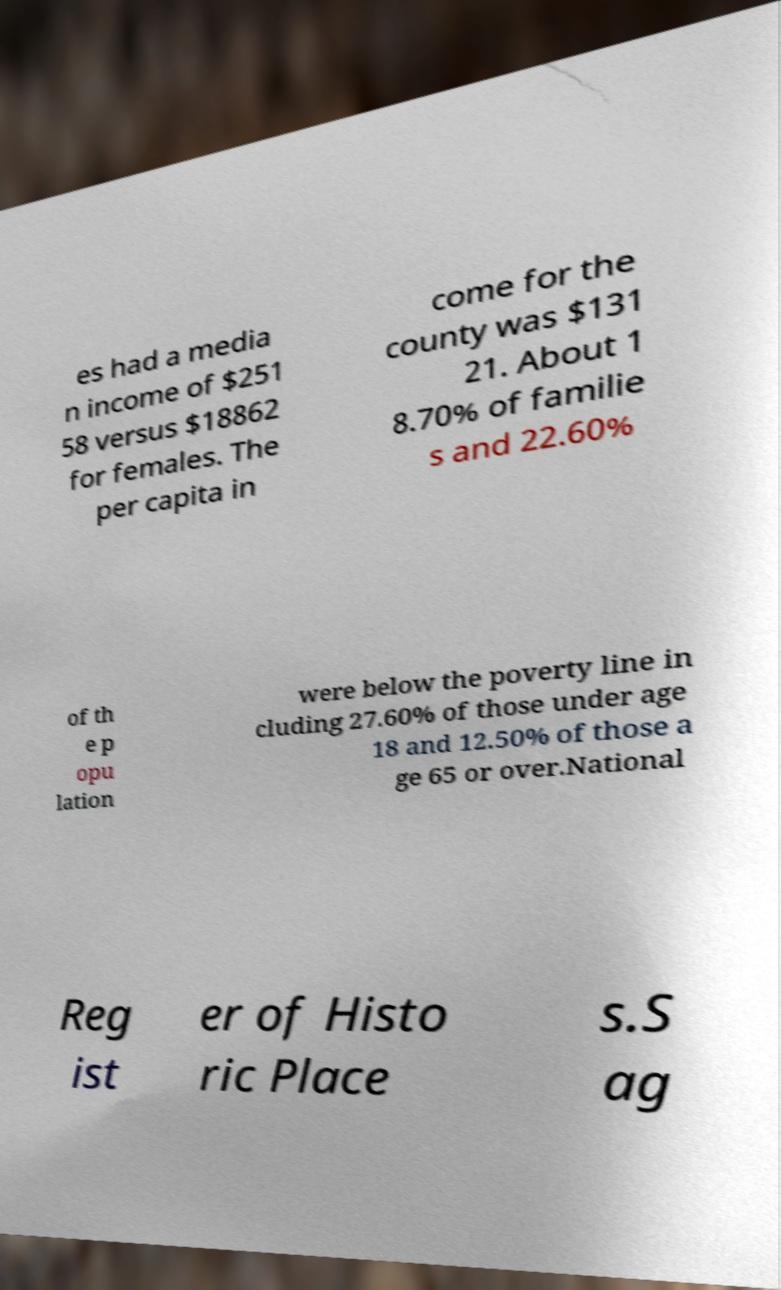Could you extract and type out the text from this image? es had a media n income of $251 58 versus $18862 for females. The per capita in come for the county was $131 21. About 1 8.70% of familie s and 22.60% of th e p opu lation were below the poverty line in cluding 27.60% of those under age 18 and 12.50% of those a ge 65 or over.National Reg ist er of Histo ric Place s.S ag 